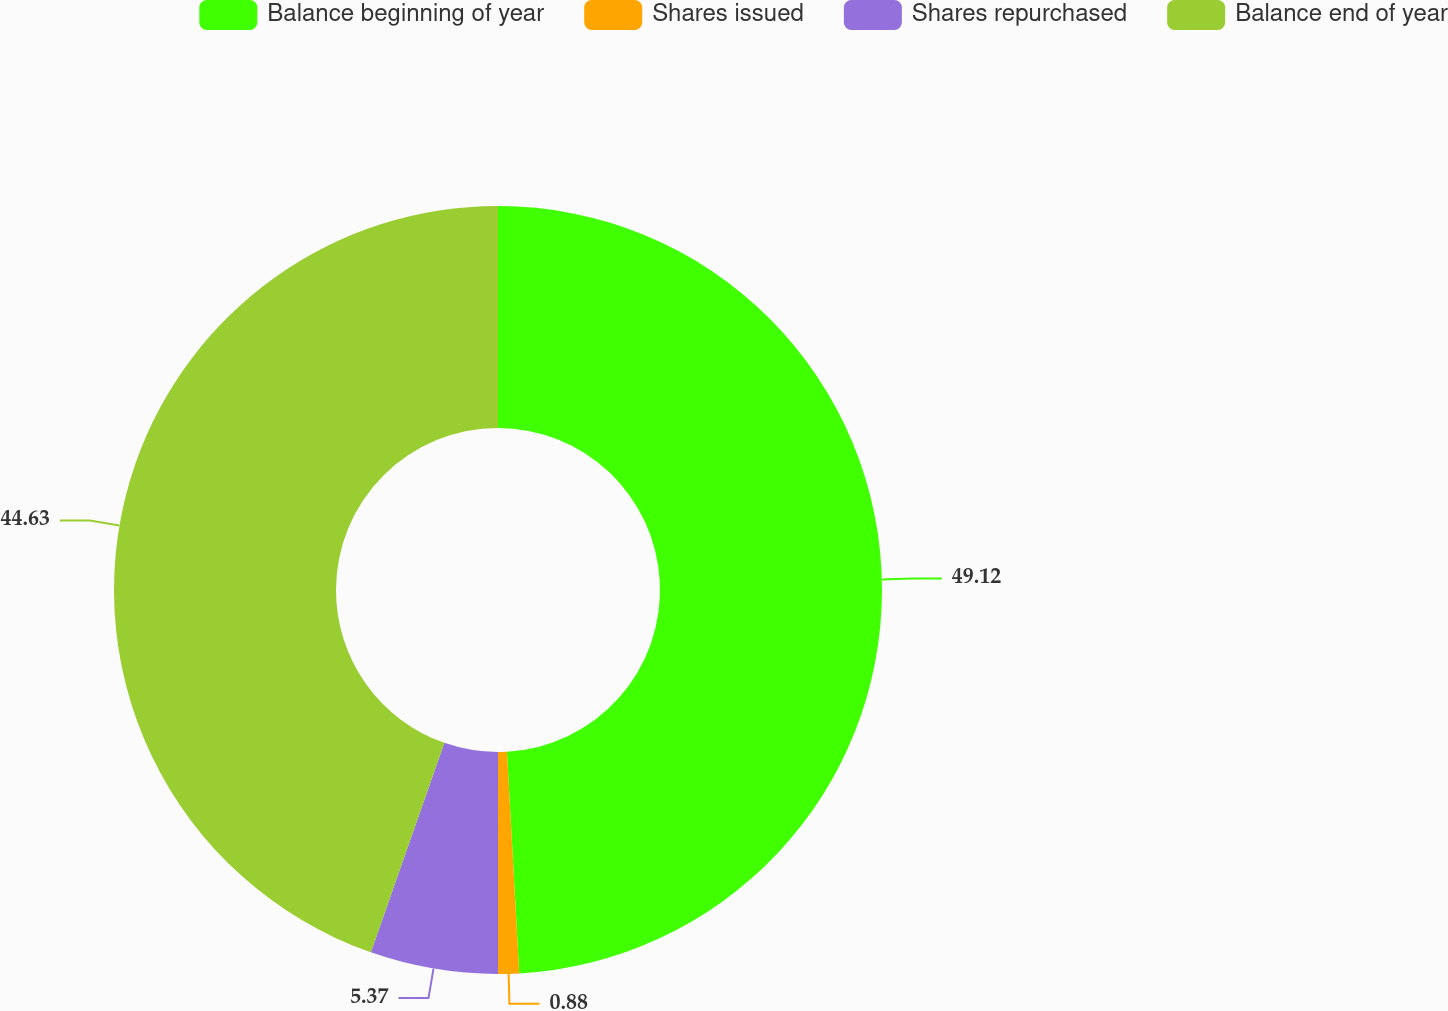<chart> <loc_0><loc_0><loc_500><loc_500><pie_chart><fcel>Balance beginning of year<fcel>Shares issued<fcel>Shares repurchased<fcel>Balance end of year<nl><fcel>49.12%<fcel>0.88%<fcel>5.37%<fcel>44.63%<nl></chart> 